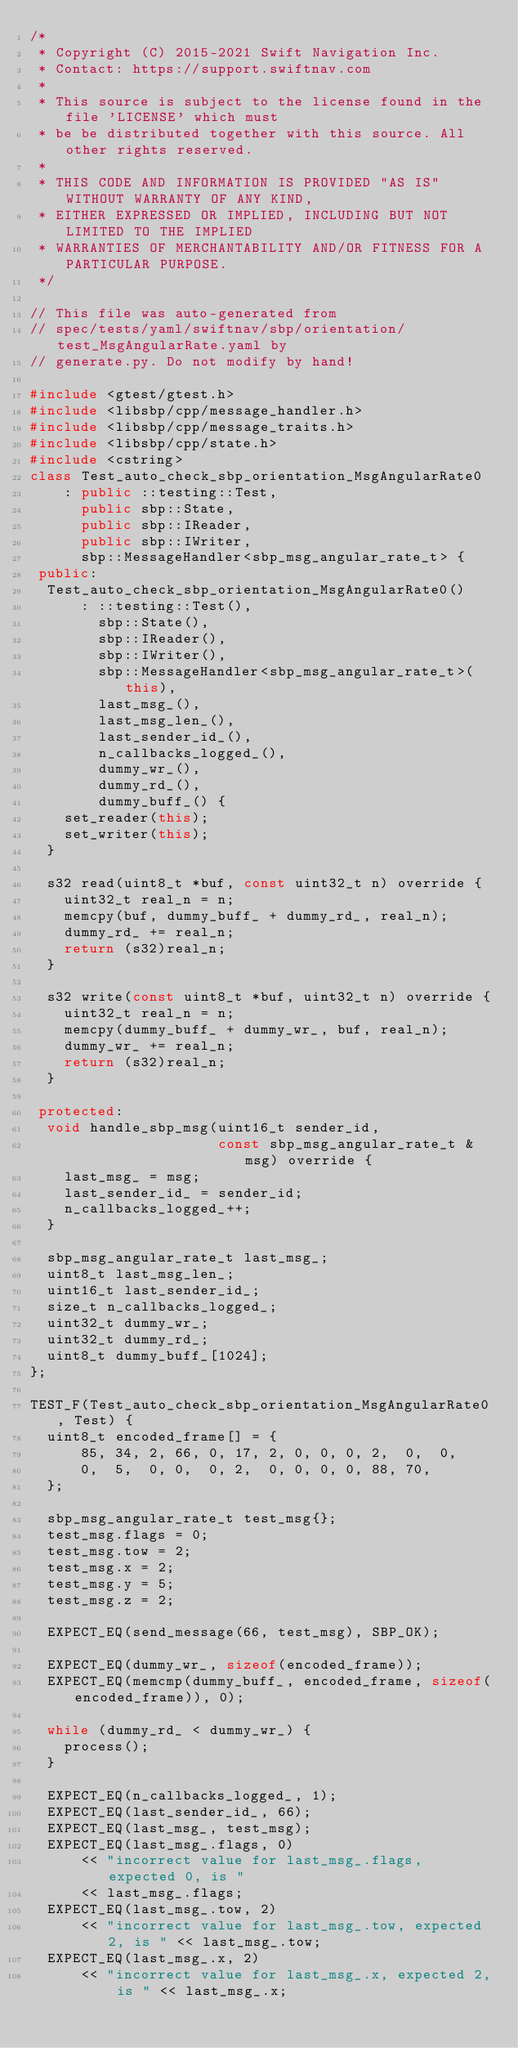<code> <loc_0><loc_0><loc_500><loc_500><_C++_>/*
 * Copyright (C) 2015-2021 Swift Navigation Inc.
 * Contact: https://support.swiftnav.com
 *
 * This source is subject to the license found in the file 'LICENSE' which must
 * be be distributed together with this source. All other rights reserved.
 *
 * THIS CODE AND INFORMATION IS PROVIDED "AS IS" WITHOUT WARRANTY OF ANY KIND,
 * EITHER EXPRESSED OR IMPLIED, INCLUDING BUT NOT LIMITED TO THE IMPLIED
 * WARRANTIES OF MERCHANTABILITY AND/OR FITNESS FOR A PARTICULAR PURPOSE.
 */

// This file was auto-generated from
// spec/tests/yaml/swiftnav/sbp/orientation/test_MsgAngularRate.yaml by
// generate.py. Do not modify by hand!

#include <gtest/gtest.h>
#include <libsbp/cpp/message_handler.h>
#include <libsbp/cpp/message_traits.h>
#include <libsbp/cpp/state.h>
#include <cstring>
class Test_auto_check_sbp_orientation_MsgAngularRate0
    : public ::testing::Test,
      public sbp::State,
      public sbp::IReader,
      public sbp::IWriter,
      sbp::MessageHandler<sbp_msg_angular_rate_t> {
 public:
  Test_auto_check_sbp_orientation_MsgAngularRate0()
      : ::testing::Test(),
        sbp::State(),
        sbp::IReader(),
        sbp::IWriter(),
        sbp::MessageHandler<sbp_msg_angular_rate_t>(this),
        last_msg_(),
        last_msg_len_(),
        last_sender_id_(),
        n_callbacks_logged_(),
        dummy_wr_(),
        dummy_rd_(),
        dummy_buff_() {
    set_reader(this);
    set_writer(this);
  }

  s32 read(uint8_t *buf, const uint32_t n) override {
    uint32_t real_n = n;
    memcpy(buf, dummy_buff_ + dummy_rd_, real_n);
    dummy_rd_ += real_n;
    return (s32)real_n;
  }

  s32 write(const uint8_t *buf, uint32_t n) override {
    uint32_t real_n = n;
    memcpy(dummy_buff_ + dummy_wr_, buf, real_n);
    dummy_wr_ += real_n;
    return (s32)real_n;
  }

 protected:
  void handle_sbp_msg(uint16_t sender_id,
                      const sbp_msg_angular_rate_t &msg) override {
    last_msg_ = msg;
    last_sender_id_ = sender_id;
    n_callbacks_logged_++;
  }

  sbp_msg_angular_rate_t last_msg_;
  uint8_t last_msg_len_;
  uint16_t last_sender_id_;
  size_t n_callbacks_logged_;
  uint32_t dummy_wr_;
  uint32_t dummy_rd_;
  uint8_t dummy_buff_[1024];
};

TEST_F(Test_auto_check_sbp_orientation_MsgAngularRate0, Test) {
  uint8_t encoded_frame[] = {
      85, 34, 2, 66, 0, 17, 2, 0, 0, 0, 2,  0,  0,
      0,  5,  0, 0,  0, 2,  0, 0, 0, 0, 88, 70,
  };

  sbp_msg_angular_rate_t test_msg{};
  test_msg.flags = 0;
  test_msg.tow = 2;
  test_msg.x = 2;
  test_msg.y = 5;
  test_msg.z = 2;

  EXPECT_EQ(send_message(66, test_msg), SBP_OK);

  EXPECT_EQ(dummy_wr_, sizeof(encoded_frame));
  EXPECT_EQ(memcmp(dummy_buff_, encoded_frame, sizeof(encoded_frame)), 0);

  while (dummy_rd_ < dummy_wr_) {
    process();
  }

  EXPECT_EQ(n_callbacks_logged_, 1);
  EXPECT_EQ(last_sender_id_, 66);
  EXPECT_EQ(last_msg_, test_msg);
  EXPECT_EQ(last_msg_.flags, 0)
      << "incorrect value for last_msg_.flags, expected 0, is "
      << last_msg_.flags;
  EXPECT_EQ(last_msg_.tow, 2)
      << "incorrect value for last_msg_.tow, expected 2, is " << last_msg_.tow;
  EXPECT_EQ(last_msg_.x, 2)
      << "incorrect value for last_msg_.x, expected 2, is " << last_msg_.x;</code> 